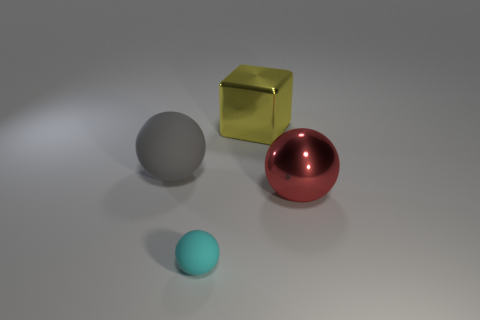Add 1 large red matte balls. How many objects exist? 5 Subtract all cubes. How many objects are left? 3 Subtract all cyan balls. Subtract all large yellow metallic blocks. How many objects are left? 2 Add 2 large red balls. How many large red balls are left? 3 Add 2 brown metal objects. How many brown metal objects exist? 2 Subtract 0 red cylinders. How many objects are left? 4 